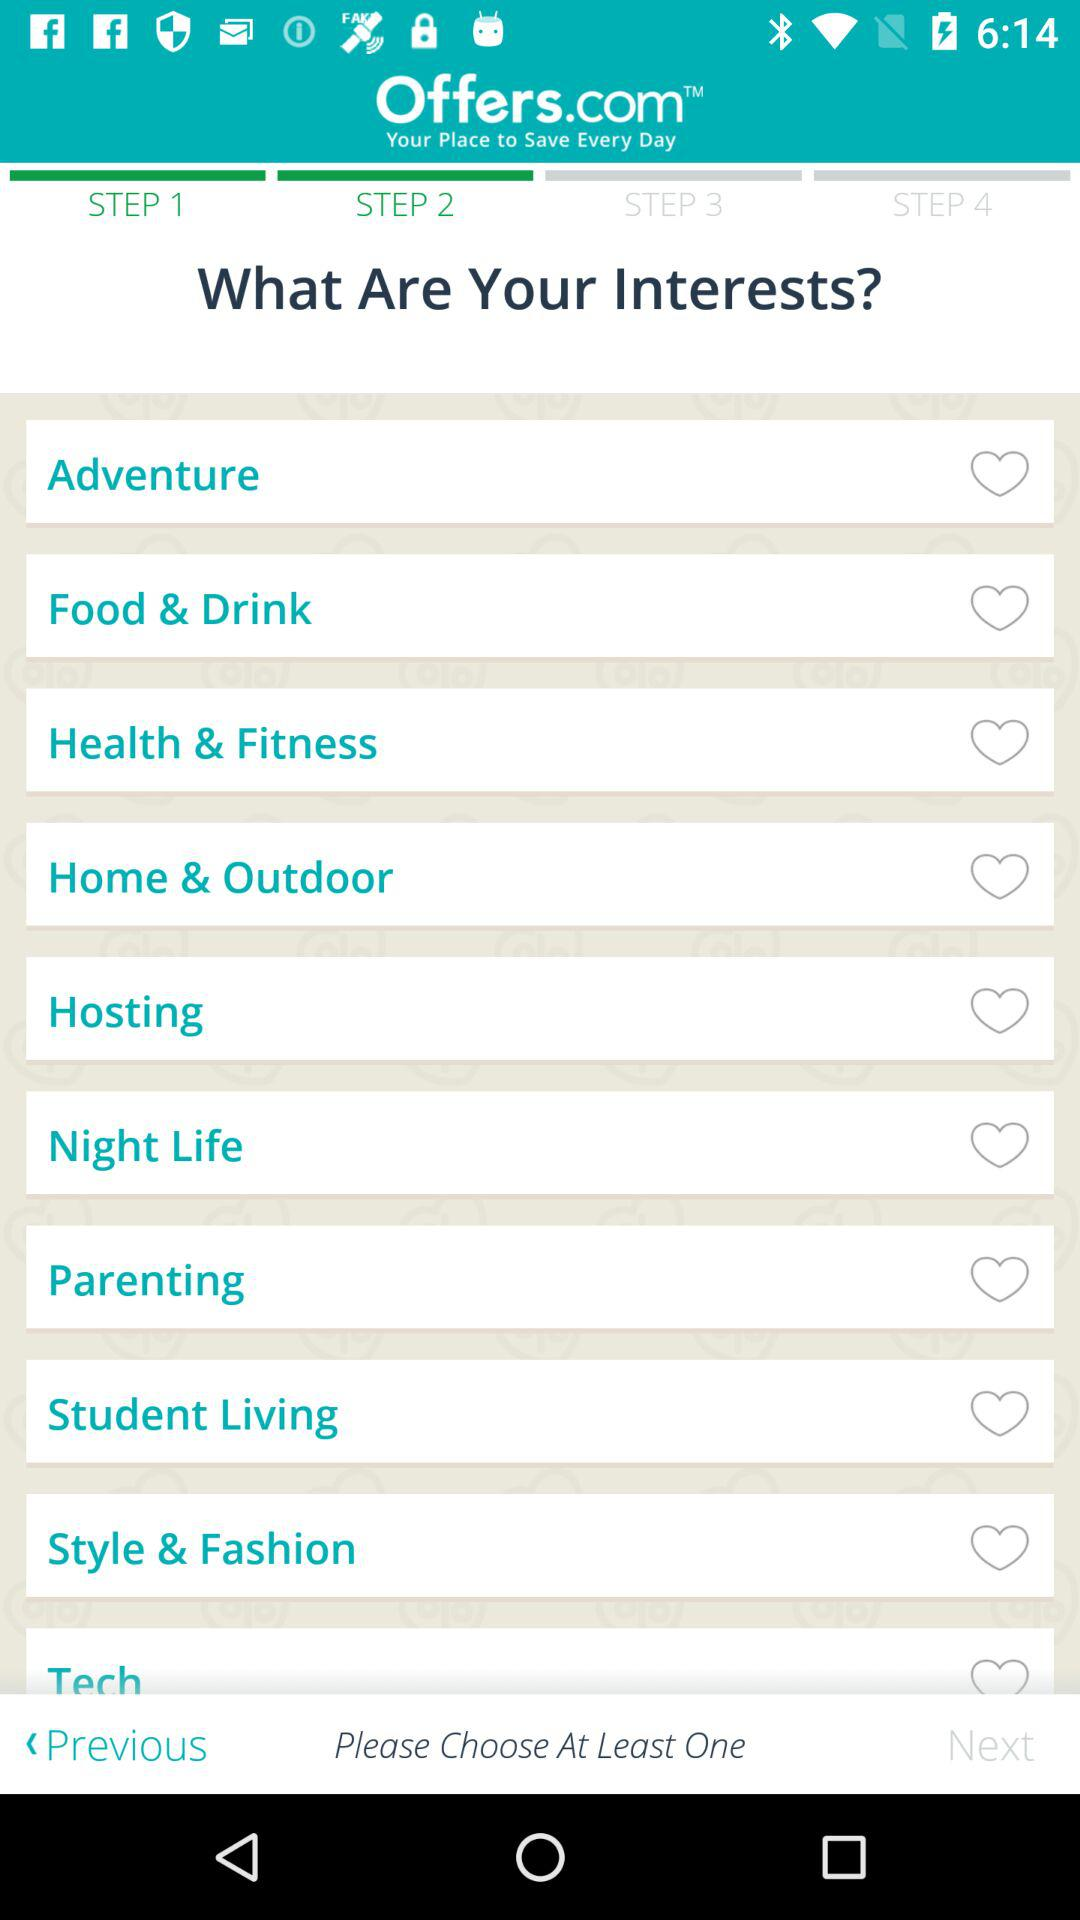Which step are we on? You are on the second step. 